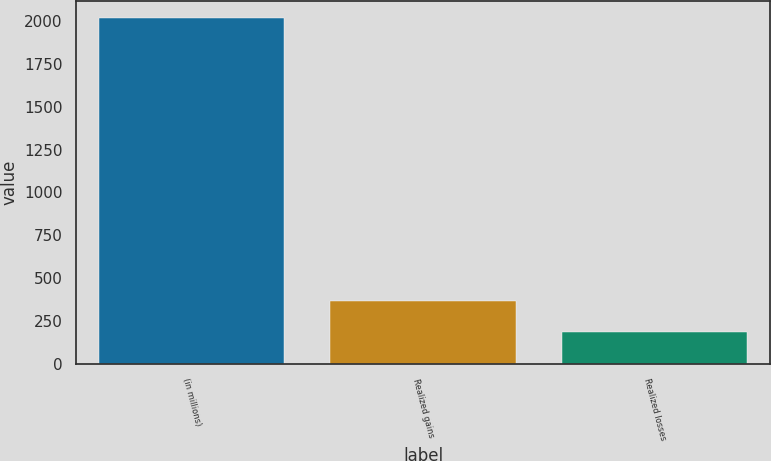<chart> <loc_0><loc_0><loc_500><loc_500><bar_chart><fcel>(in millions)<fcel>Realized gains<fcel>Realized losses<nl><fcel>2016<fcel>369.9<fcel>187<nl></chart> 